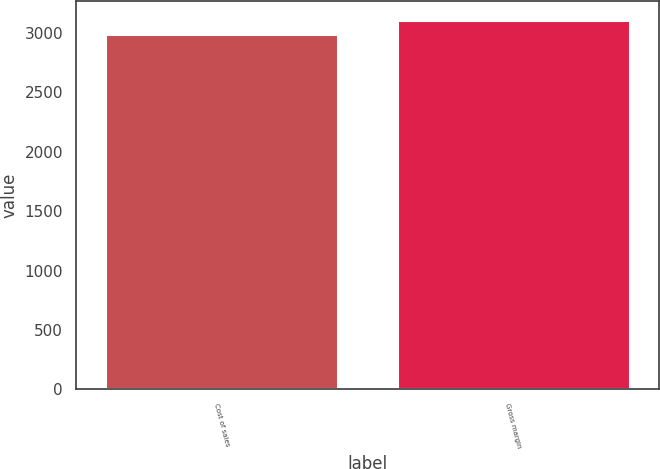Convert chart to OTSL. <chart><loc_0><loc_0><loc_500><loc_500><bar_chart><fcel>Cost of sales<fcel>Gross margin<nl><fcel>2990.7<fcel>3113.3<nl></chart> 